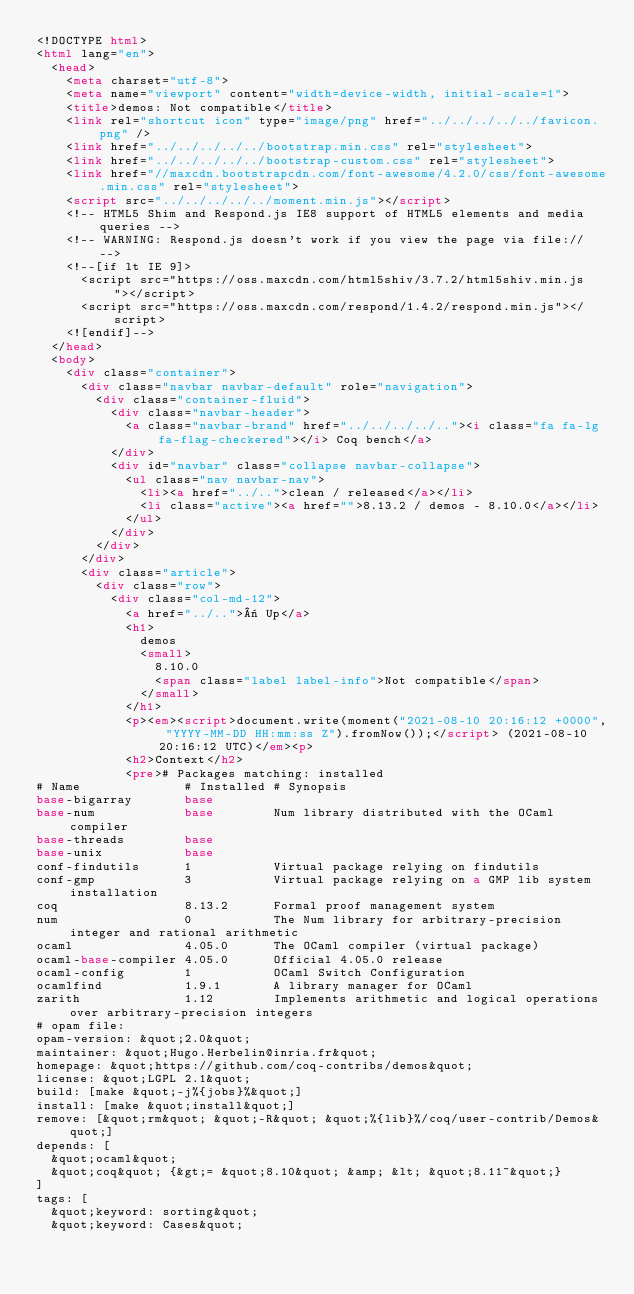<code> <loc_0><loc_0><loc_500><loc_500><_HTML_><!DOCTYPE html>
<html lang="en">
  <head>
    <meta charset="utf-8">
    <meta name="viewport" content="width=device-width, initial-scale=1">
    <title>demos: Not compatible</title>
    <link rel="shortcut icon" type="image/png" href="../../../../../favicon.png" />
    <link href="../../../../../bootstrap.min.css" rel="stylesheet">
    <link href="../../../../../bootstrap-custom.css" rel="stylesheet">
    <link href="//maxcdn.bootstrapcdn.com/font-awesome/4.2.0/css/font-awesome.min.css" rel="stylesheet">
    <script src="../../../../../moment.min.js"></script>
    <!-- HTML5 Shim and Respond.js IE8 support of HTML5 elements and media queries -->
    <!-- WARNING: Respond.js doesn't work if you view the page via file:// -->
    <!--[if lt IE 9]>
      <script src="https://oss.maxcdn.com/html5shiv/3.7.2/html5shiv.min.js"></script>
      <script src="https://oss.maxcdn.com/respond/1.4.2/respond.min.js"></script>
    <![endif]-->
  </head>
  <body>
    <div class="container">
      <div class="navbar navbar-default" role="navigation">
        <div class="container-fluid">
          <div class="navbar-header">
            <a class="navbar-brand" href="../../../../.."><i class="fa fa-lg fa-flag-checkered"></i> Coq bench</a>
          </div>
          <div id="navbar" class="collapse navbar-collapse">
            <ul class="nav navbar-nav">
              <li><a href="../..">clean / released</a></li>
              <li class="active"><a href="">8.13.2 / demos - 8.10.0</a></li>
            </ul>
          </div>
        </div>
      </div>
      <div class="article">
        <div class="row">
          <div class="col-md-12">
            <a href="../..">« Up</a>
            <h1>
              demos
              <small>
                8.10.0
                <span class="label label-info">Not compatible</span>
              </small>
            </h1>
            <p><em><script>document.write(moment("2021-08-10 20:16:12 +0000", "YYYY-MM-DD HH:mm:ss Z").fromNow());</script> (2021-08-10 20:16:12 UTC)</em><p>
            <h2>Context</h2>
            <pre># Packages matching: installed
# Name              # Installed # Synopsis
base-bigarray       base
base-num            base        Num library distributed with the OCaml compiler
base-threads        base
base-unix           base
conf-findutils      1           Virtual package relying on findutils
conf-gmp            3           Virtual package relying on a GMP lib system installation
coq                 8.13.2      Formal proof management system
num                 0           The Num library for arbitrary-precision integer and rational arithmetic
ocaml               4.05.0      The OCaml compiler (virtual package)
ocaml-base-compiler 4.05.0      Official 4.05.0 release
ocaml-config        1           OCaml Switch Configuration
ocamlfind           1.9.1       A library manager for OCaml
zarith              1.12        Implements arithmetic and logical operations over arbitrary-precision integers
# opam file:
opam-version: &quot;2.0&quot;
maintainer: &quot;Hugo.Herbelin@inria.fr&quot;
homepage: &quot;https://github.com/coq-contribs/demos&quot;
license: &quot;LGPL 2.1&quot;
build: [make &quot;-j%{jobs}%&quot;]
install: [make &quot;install&quot;]
remove: [&quot;rm&quot; &quot;-R&quot; &quot;%{lib}%/coq/user-contrib/Demos&quot;]
depends: [
  &quot;ocaml&quot;
  &quot;coq&quot; {&gt;= &quot;8.10&quot; &amp; &lt; &quot;8.11~&quot;}
]
tags: [
  &quot;keyword: sorting&quot;
  &quot;keyword: Cases&quot;</code> 